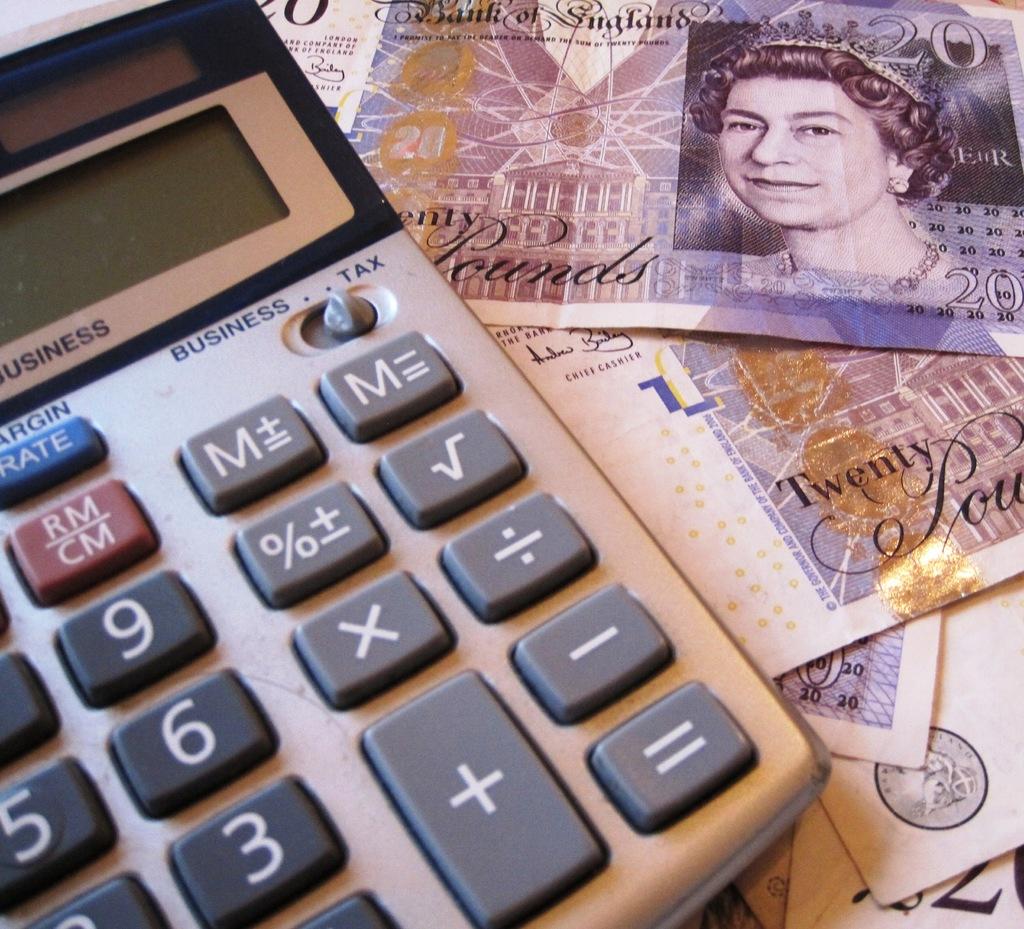What country does the currency belong to?
Make the answer very short. England. How much is the dollar bills worth?
Give a very brief answer. 20. 